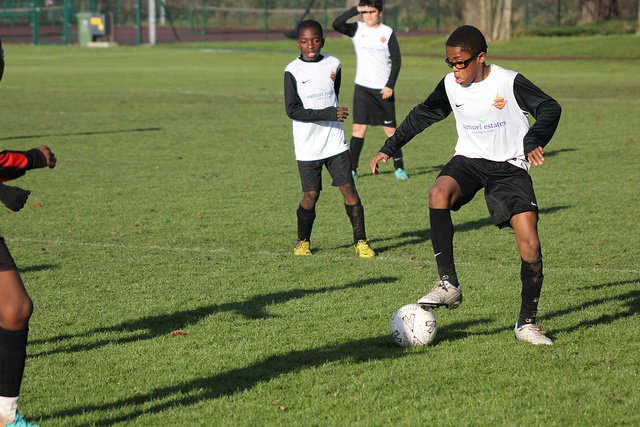Describe the objects in this image and their specific colors. I can see people in black, white, olive, and brown tones, people in black, white, and olive tones, people in black, brown, olive, and maroon tones, people in black, white, tan, and gray tones, and sports ball in black, ivory, darkgray, gray, and tan tones in this image. 